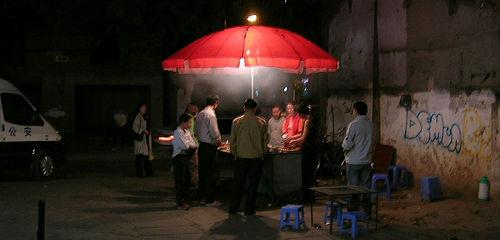What is happening under the umbrella?

Choices:
A) cleaning up
B) food sales
C) card game
D) discussion food sales 